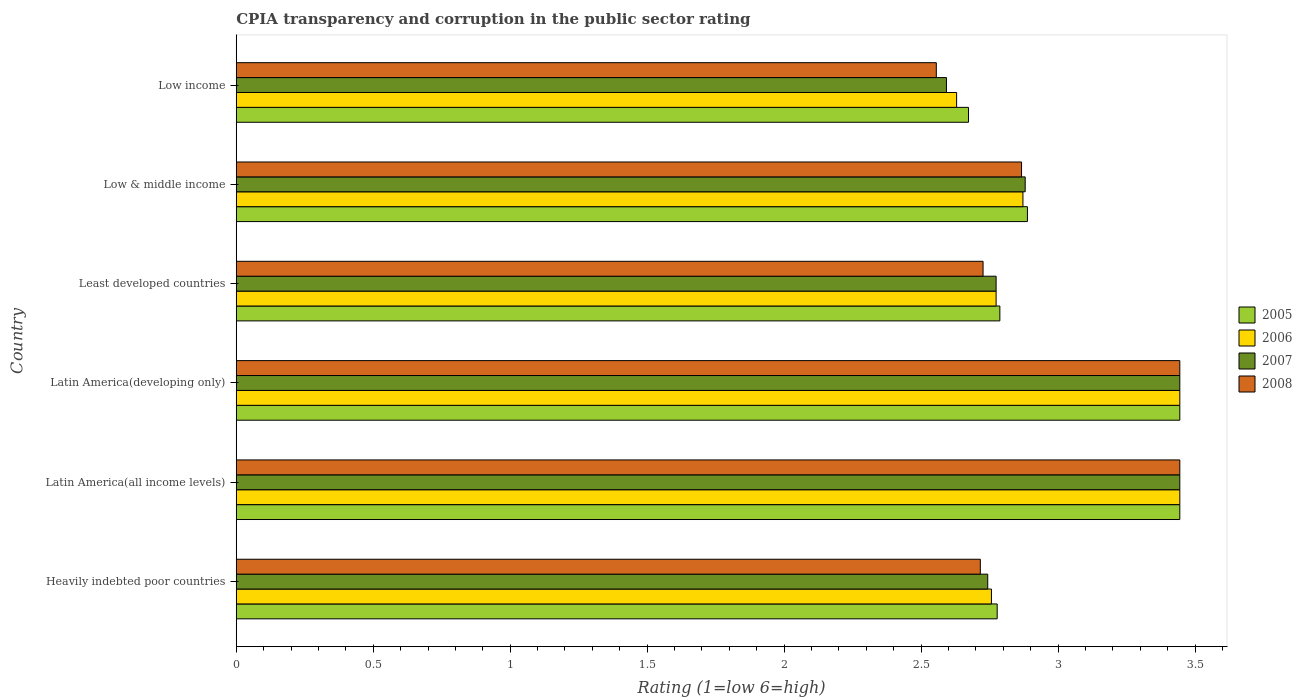Are the number of bars on each tick of the Y-axis equal?
Make the answer very short. Yes. How many bars are there on the 4th tick from the top?
Offer a terse response. 4. What is the label of the 3rd group of bars from the top?
Offer a terse response. Least developed countries. What is the CPIA rating in 2007 in Least developed countries?
Your response must be concise. 2.77. Across all countries, what is the maximum CPIA rating in 2005?
Provide a succinct answer. 3.44. Across all countries, what is the minimum CPIA rating in 2006?
Give a very brief answer. 2.63. In which country was the CPIA rating in 2007 maximum?
Provide a succinct answer. Latin America(all income levels). What is the total CPIA rating in 2005 in the graph?
Provide a succinct answer. 18.02. What is the difference between the CPIA rating in 2005 in Heavily indebted poor countries and that in Low & middle income?
Offer a very short reply. -0.11. What is the difference between the CPIA rating in 2005 in Least developed countries and the CPIA rating in 2007 in Low income?
Give a very brief answer. 0.19. What is the average CPIA rating in 2005 per country?
Provide a short and direct response. 3. What is the difference between the CPIA rating in 2005 and CPIA rating in 2006 in Least developed countries?
Keep it short and to the point. 0.01. In how many countries, is the CPIA rating in 2006 greater than 1.5 ?
Your answer should be very brief. 6. What is the ratio of the CPIA rating in 2005 in Latin America(all income levels) to that in Latin America(developing only)?
Your answer should be compact. 1. Is the CPIA rating in 2005 in Least developed countries less than that in Low income?
Provide a short and direct response. No. What is the difference between the highest and the lowest CPIA rating in 2007?
Your answer should be very brief. 0.85. In how many countries, is the CPIA rating in 2005 greater than the average CPIA rating in 2005 taken over all countries?
Give a very brief answer. 2. What does the 3rd bar from the top in Least developed countries represents?
Offer a very short reply. 2006. Is it the case that in every country, the sum of the CPIA rating in 2005 and CPIA rating in 2006 is greater than the CPIA rating in 2008?
Your answer should be compact. Yes. How many bars are there?
Keep it short and to the point. 24. Are all the bars in the graph horizontal?
Offer a terse response. Yes. What is the difference between two consecutive major ticks on the X-axis?
Ensure brevity in your answer.  0.5. Does the graph contain any zero values?
Provide a short and direct response. No. Does the graph contain grids?
Give a very brief answer. No. How are the legend labels stacked?
Offer a terse response. Vertical. What is the title of the graph?
Your answer should be compact. CPIA transparency and corruption in the public sector rating. What is the label or title of the Y-axis?
Offer a very short reply. Country. What is the Rating (1=low 6=high) of 2005 in Heavily indebted poor countries?
Provide a short and direct response. 2.78. What is the Rating (1=low 6=high) of 2006 in Heavily indebted poor countries?
Keep it short and to the point. 2.76. What is the Rating (1=low 6=high) of 2007 in Heavily indebted poor countries?
Give a very brief answer. 2.74. What is the Rating (1=low 6=high) in 2008 in Heavily indebted poor countries?
Give a very brief answer. 2.72. What is the Rating (1=low 6=high) of 2005 in Latin America(all income levels)?
Provide a short and direct response. 3.44. What is the Rating (1=low 6=high) in 2006 in Latin America(all income levels)?
Your answer should be compact. 3.44. What is the Rating (1=low 6=high) in 2007 in Latin America(all income levels)?
Your answer should be compact. 3.44. What is the Rating (1=low 6=high) in 2008 in Latin America(all income levels)?
Keep it short and to the point. 3.44. What is the Rating (1=low 6=high) in 2005 in Latin America(developing only)?
Keep it short and to the point. 3.44. What is the Rating (1=low 6=high) in 2006 in Latin America(developing only)?
Offer a very short reply. 3.44. What is the Rating (1=low 6=high) of 2007 in Latin America(developing only)?
Offer a very short reply. 3.44. What is the Rating (1=low 6=high) of 2008 in Latin America(developing only)?
Your answer should be compact. 3.44. What is the Rating (1=low 6=high) of 2005 in Least developed countries?
Offer a terse response. 2.79. What is the Rating (1=low 6=high) of 2006 in Least developed countries?
Offer a very short reply. 2.77. What is the Rating (1=low 6=high) in 2007 in Least developed countries?
Your response must be concise. 2.77. What is the Rating (1=low 6=high) in 2008 in Least developed countries?
Keep it short and to the point. 2.73. What is the Rating (1=low 6=high) in 2005 in Low & middle income?
Give a very brief answer. 2.89. What is the Rating (1=low 6=high) in 2006 in Low & middle income?
Provide a succinct answer. 2.87. What is the Rating (1=low 6=high) in 2007 in Low & middle income?
Your answer should be compact. 2.88. What is the Rating (1=low 6=high) in 2008 in Low & middle income?
Your answer should be compact. 2.87. What is the Rating (1=low 6=high) of 2005 in Low income?
Provide a short and direct response. 2.67. What is the Rating (1=low 6=high) of 2006 in Low income?
Your answer should be compact. 2.63. What is the Rating (1=low 6=high) in 2007 in Low income?
Offer a very short reply. 2.59. What is the Rating (1=low 6=high) of 2008 in Low income?
Offer a terse response. 2.56. Across all countries, what is the maximum Rating (1=low 6=high) in 2005?
Provide a short and direct response. 3.44. Across all countries, what is the maximum Rating (1=low 6=high) of 2006?
Your response must be concise. 3.44. Across all countries, what is the maximum Rating (1=low 6=high) in 2007?
Keep it short and to the point. 3.44. Across all countries, what is the maximum Rating (1=low 6=high) of 2008?
Provide a succinct answer. 3.44. Across all countries, what is the minimum Rating (1=low 6=high) in 2005?
Give a very brief answer. 2.67. Across all countries, what is the minimum Rating (1=low 6=high) of 2006?
Your answer should be compact. 2.63. Across all countries, what is the minimum Rating (1=low 6=high) in 2007?
Keep it short and to the point. 2.59. Across all countries, what is the minimum Rating (1=low 6=high) of 2008?
Keep it short and to the point. 2.56. What is the total Rating (1=low 6=high) of 2005 in the graph?
Offer a very short reply. 18.02. What is the total Rating (1=low 6=high) in 2006 in the graph?
Keep it short and to the point. 17.92. What is the total Rating (1=low 6=high) of 2007 in the graph?
Ensure brevity in your answer.  17.88. What is the total Rating (1=low 6=high) in 2008 in the graph?
Offer a terse response. 17.75. What is the difference between the Rating (1=low 6=high) in 2006 in Heavily indebted poor countries and that in Latin America(all income levels)?
Your answer should be compact. -0.69. What is the difference between the Rating (1=low 6=high) of 2007 in Heavily indebted poor countries and that in Latin America(all income levels)?
Give a very brief answer. -0.7. What is the difference between the Rating (1=low 6=high) in 2008 in Heavily indebted poor countries and that in Latin America(all income levels)?
Offer a very short reply. -0.73. What is the difference between the Rating (1=low 6=high) in 2006 in Heavily indebted poor countries and that in Latin America(developing only)?
Ensure brevity in your answer.  -0.69. What is the difference between the Rating (1=low 6=high) in 2007 in Heavily indebted poor countries and that in Latin America(developing only)?
Your answer should be compact. -0.7. What is the difference between the Rating (1=low 6=high) of 2008 in Heavily indebted poor countries and that in Latin America(developing only)?
Your response must be concise. -0.73. What is the difference between the Rating (1=low 6=high) of 2005 in Heavily indebted poor countries and that in Least developed countries?
Offer a very short reply. -0.01. What is the difference between the Rating (1=low 6=high) in 2006 in Heavily indebted poor countries and that in Least developed countries?
Give a very brief answer. -0.02. What is the difference between the Rating (1=low 6=high) in 2007 in Heavily indebted poor countries and that in Least developed countries?
Ensure brevity in your answer.  -0.03. What is the difference between the Rating (1=low 6=high) in 2008 in Heavily indebted poor countries and that in Least developed countries?
Your answer should be very brief. -0.01. What is the difference between the Rating (1=low 6=high) in 2005 in Heavily indebted poor countries and that in Low & middle income?
Provide a short and direct response. -0.11. What is the difference between the Rating (1=low 6=high) of 2006 in Heavily indebted poor countries and that in Low & middle income?
Provide a succinct answer. -0.12. What is the difference between the Rating (1=low 6=high) in 2007 in Heavily indebted poor countries and that in Low & middle income?
Give a very brief answer. -0.14. What is the difference between the Rating (1=low 6=high) in 2008 in Heavily indebted poor countries and that in Low & middle income?
Offer a very short reply. -0.15. What is the difference between the Rating (1=low 6=high) in 2005 in Heavily indebted poor countries and that in Low income?
Keep it short and to the point. 0.1. What is the difference between the Rating (1=low 6=high) in 2006 in Heavily indebted poor countries and that in Low income?
Give a very brief answer. 0.13. What is the difference between the Rating (1=low 6=high) of 2007 in Heavily indebted poor countries and that in Low income?
Your answer should be very brief. 0.15. What is the difference between the Rating (1=low 6=high) of 2008 in Heavily indebted poor countries and that in Low income?
Provide a short and direct response. 0.16. What is the difference between the Rating (1=low 6=high) in 2005 in Latin America(all income levels) and that in Latin America(developing only)?
Provide a short and direct response. 0. What is the difference between the Rating (1=low 6=high) of 2008 in Latin America(all income levels) and that in Latin America(developing only)?
Your answer should be compact. 0. What is the difference between the Rating (1=low 6=high) of 2005 in Latin America(all income levels) and that in Least developed countries?
Your answer should be compact. 0.66. What is the difference between the Rating (1=low 6=high) of 2006 in Latin America(all income levels) and that in Least developed countries?
Provide a short and direct response. 0.67. What is the difference between the Rating (1=low 6=high) in 2007 in Latin America(all income levels) and that in Least developed countries?
Offer a very short reply. 0.67. What is the difference between the Rating (1=low 6=high) in 2008 in Latin America(all income levels) and that in Least developed countries?
Keep it short and to the point. 0.72. What is the difference between the Rating (1=low 6=high) of 2005 in Latin America(all income levels) and that in Low & middle income?
Your answer should be very brief. 0.56. What is the difference between the Rating (1=low 6=high) in 2006 in Latin America(all income levels) and that in Low & middle income?
Your answer should be compact. 0.57. What is the difference between the Rating (1=low 6=high) of 2007 in Latin America(all income levels) and that in Low & middle income?
Your response must be concise. 0.56. What is the difference between the Rating (1=low 6=high) in 2008 in Latin America(all income levels) and that in Low & middle income?
Your answer should be very brief. 0.58. What is the difference between the Rating (1=low 6=high) in 2005 in Latin America(all income levels) and that in Low income?
Ensure brevity in your answer.  0.77. What is the difference between the Rating (1=low 6=high) in 2006 in Latin America(all income levels) and that in Low income?
Provide a succinct answer. 0.81. What is the difference between the Rating (1=low 6=high) of 2007 in Latin America(all income levels) and that in Low income?
Offer a terse response. 0.85. What is the difference between the Rating (1=low 6=high) in 2008 in Latin America(all income levels) and that in Low income?
Offer a very short reply. 0.89. What is the difference between the Rating (1=low 6=high) of 2005 in Latin America(developing only) and that in Least developed countries?
Give a very brief answer. 0.66. What is the difference between the Rating (1=low 6=high) in 2006 in Latin America(developing only) and that in Least developed countries?
Make the answer very short. 0.67. What is the difference between the Rating (1=low 6=high) in 2007 in Latin America(developing only) and that in Least developed countries?
Offer a terse response. 0.67. What is the difference between the Rating (1=low 6=high) of 2008 in Latin America(developing only) and that in Least developed countries?
Provide a short and direct response. 0.72. What is the difference between the Rating (1=low 6=high) in 2005 in Latin America(developing only) and that in Low & middle income?
Offer a very short reply. 0.56. What is the difference between the Rating (1=low 6=high) in 2006 in Latin America(developing only) and that in Low & middle income?
Your response must be concise. 0.57. What is the difference between the Rating (1=low 6=high) of 2007 in Latin America(developing only) and that in Low & middle income?
Make the answer very short. 0.56. What is the difference between the Rating (1=low 6=high) of 2008 in Latin America(developing only) and that in Low & middle income?
Your answer should be very brief. 0.58. What is the difference between the Rating (1=low 6=high) of 2005 in Latin America(developing only) and that in Low income?
Give a very brief answer. 0.77. What is the difference between the Rating (1=low 6=high) in 2006 in Latin America(developing only) and that in Low income?
Offer a terse response. 0.81. What is the difference between the Rating (1=low 6=high) of 2007 in Latin America(developing only) and that in Low income?
Your response must be concise. 0.85. What is the difference between the Rating (1=low 6=high) of 2005 in Least developed countries and that in Low & middle income?
Offer a very short reply. -0.1. What is the difference between the Rating (1=low 6=high) in 2006 in Least developed countries and that in Low & middle income?
Your answer should be compact. -0.1. What is the difference between the Rating (1=low 6=high) in 2007 in Least developed countries and that in Low & middle income?
Provide a short and direct response. -0.11. What is the difference between the Rating (1=low 6=high) in 2008 in Least developed countries and that in Low & middle income?
Your answer should be compact. -0.14. What is the difference between the Rating (1=low 6=high) in 2005 in Least developed countries and that in Low income?
Your response must be concise. 0.11. What is the difference between the Rating (1=low 6=high) of 2006 in Least developed countries and that in Low income?
Offer a very short reply. 0.14. What is the difference between the Rating (1=low 6=high) of 2007 in Least developed countries and that in Low income?
Your answer should be compact. 0.18. What is the difference between the Rating (1=low 6=high) in 2008 in Least developed countries and that in Low income?
Ensure brevity in your answer.  0.17. What is the difference between the Rating (1=low 6=high) of 2005 in Low & middle income and that in Low income?
Make the answer very short. 0.22. What is the difference between the Rating (1=low 6=high) in 2006 in Low & middle income and that in Low income?
Make the answer very short. 0.24. What is the difference between the Rating (1=low 6=high) in 2007 in Low & middle income and that in Low income?
Your response must be concise. 0.29. What is the difference between the Rating (1=low 6=high) of 2008 in Low & middle income and that in Low income?
Give a very brief answer. 0.31. What is the difference between the Rating (1=low 6=high) of 2006 in Heavily indebted poor countries and the Rating (1=low 6=high) of 2007 in Latin America(all income levels)?
Your answer should be very brief. -0.69. What is the difference between the Rating (1=low 6=high) in 2006 in Heavily indebted poor countries and the Rating (1=low 6=high) in 2008 in Latin America(all income levels)?
Your answer should be very brief. -0.69. What is the difference between the Rating (1=low 6=high) in 2007 in Heavily indebted poor countries and the Rating (1=low 6=high) in 2008 in Latin America(all income levels)?
Keep it short and to the point. -0.7. What is the difference between the Rating (1=low 6=high) of 2005 in Heavily indebted poor countries and the Rating (1=low 6=high) of 2006 in Latin America(developing only)?
Provide a short and direct response. -0.67. What is the difference between the Rating (1=low 6=high) in 2006 in Heavily indebted poor countries and the Rating (1=low 6=high) in 2007 in Latin America(developing only)?
Keep it short and to the point. -0.69. What is the difference between the Rating (1=low 6=high) of 2006 in Heavily indebted poor countries and the Rating (1=low 6=high) of 2008 in Latin America(developing only)?
Give a very brief answer. -0.69. What is the difference between the Rating (1=low 6=high) in 2007 in Heavily indebted poor countries and the Rating (1=low 6=high) in 2008 in Latin America(developing only)?
Your response must be concise. -0.7. What is the difference between the Rating (1=low 6=high) in 2005 in Heavily indebted poor countries and the Rating (1=low 6=high) in 2006 in Least developed countries?
Provide a succinct answer. 0. What is the difference between the Rating (1=low 6=high) in 2005 in Heavily indebted poor countries and the Rating (1=low 6=high) in 2007 in Least developed countries?
Make the answer very short. 0. What is the difference between the Rating (1=low 6=high) of 2005 in Heavily indebted poor countries and the Rating (1=low 6=high) of 2008 in Least developed countries?
Your answer should be very brief. 0.05. What is the difference between the Rating (1=low 6=high) of 2006 in Heavily indebted poor countries and the Rating (1=low 6=high) of 2007 in Least developed countries?
Keep it short and to the point. -0.02. What is the difference between the Rating (1=low 6=high) in 2006 in Heavily indebted poor countries and the Rating (1=low 6=high) in 2008 in Least developed countries?
Ensure brevity in your answer.  0.03. What is the difference between the Rating (1=low 6=high) of 2007 in Heavily indebted poor countries and the Rating (1=low 6=high) of 2008 in Least developed countries?
Offer a terse response. 0.02. What is the difference between the Rating (1=low 6=high) in 2005 in Heavily indebted poor countries and the Rating (1=low 6=high) in 2006 in Low & middle income?
Your answer should be compact. -0.09. What is the difference between the Rating (1=low 6=high) in 2005 in Heavily indebted poor countries and the Rating (1=low 6=high) in 2007 in Low & middle income?
Provide a short and direct response. -0.1. What is the difference between the Rating (1=low 6=high) in 2005 in Heavily indebted poor countries and the Rating (1=low 6=high) in 2008 in Low & middle income?
Provide a short and direct response. -0.09. What is the difference between the Rating (1=low 6=high) in 2006 in Heavily indebted poor countries and the Rating (1=low 6=high) in 2007 in Low & middle income?
Provide a succinct answer. -0.12. What is the difference between the Rating (1=low 6=high) in 2006 in Heavily indebted poor countries and the Rating (1=low 6=high) in 2008 in Low & middle income?
Give a very brief answer. -0.11. What is the difference between the Rating (1=low 6=high) in 2007 in Heavily indebted poor countries and the Rating (1=low 6=high) in 2008 in Low & middle income?
Provide a succinct answer. -0.12. What is the difference between the Rating (1=low 6=high) of 2005 in Heavily indebted poor countries and the Rating (1=low 6=high) of 2006 in Low income?
Keep it short and to the point. 0.15. What is the difference between the Rating (1=low 6=high) of 2005 in Heavily indebted poor countries and the Rating (1=low 6=high) of 2007 in Low income?
Your answer should be compact. 0.19. What is the difference between the Rating (1=low 6=high) of 2005 in Heavily indebted poor countries and the Rating (1=low 6=high) of 2008 in Low income?
Give a very brief answer. 0.22. What is the difference between the Rating (1=low 6=high) of 2006 in Heavily indebted poor countries and the Rating (1=low 6=high) of 2007 in Low income?
Provide a short and direct response. 0.16. What is the difference between the Rating (1=low 6=high) of 2006 in Heavily indebted poor countries and the Rating (1=low 6=high) of 2008 in Low income?
Give a very brief answer. 0.2. What is the difference between the Rating (1=low 6=high) in 2007 in Heavily indebted poor countries and the Rating (1=low 6=high) in 2008 in Low income?
Your answer should be compact. 0.19. What is the difference between the Rating (1=low 6=high) of 2006 in Latin America(all income levels) and the Rating (1=low 6=high) of 2007 in Latin America(developing only)?
Provide a short and direct response. 0. What is the difference between the Rating (1=low 6=high) in 2007 in Latin America(all income levels) and the Rating (1=low 6=high) in 2008 in Latin America(developing only)?
Your answer should be compact. 0. What is the difference between the Rating (1=low 6=high) of 2005 in Latin America(all income levels) and the Rating (1=low 6=high) of 2006 in Least developed countries?
Keep it short and to the point. 0.67. What is the difference between the Rating (1=low 6=high) in 2005 in Latin America(all income levels) and the Rating (1=low 6=high) in 2007 in Least developed countries?
Your response must be concise. 0.67. What is the difference between the Rating (1=low 6=high) of 2005 in Latin America(all income levels) and the Rating (1=low 6=high) of 2008 in Least developed countries?
Provide a short and direct response. 0.72. What is the difference between the Rating (1=low 6=high) in 2006 in Latin America(all income levels) and the Rating (1=low 6=high) in 2007 in Least developed countries?
Offer a very short reply. 0.67. What is the difference between the Rating (1=low 6=high) in 2006 in Latin America(all income levels) and the Rating (1=low 6=high) in 2008 in Least developed countries?
Offer a terse response. 0.72. What is the difference between the Rating (1=low 6=high) in 2007 in Latin America(all income levels) and the Rating (1=low 6=high) in 2008 in Least developed countries?
Provide a short and direct response. 0.72. What is the difference between the Rating (1=low 6=high) of 2005 in Latin America(all income levels) and the Rating (1=low 6=high) of 2006 in Low & middle income?
Keep it short and to the point. 0.57. What is the difference between the Rating (1=low 6=high) of 2005 in Latin America(all income levels) and the Rating (1=low 6=high) of 2007 in Low & middle income?
Offer a very short reply. 0.56. What is the difference between the Rating (1=low 6=high) of 2005 in Latin America(all income levels) and the Rating (1=low 6=high) of 2008 in Low & middle income?
Offer a terse response. 0.58. What is the difference between the Rating (1=low 6=high) of 2006 in Latin America(all income levels) and the Rating (1=low 6=high) of 2007 in Low & middle income?
Your answer should be very brief. 0.56. What is the difference between the Rating (1=low 6=high) in 2006 in Latin America(all income levels) and the Rating (1=low 6=high) in 2008 in Low & middle income?
Give a very brief answer. 0.58. What is the difference between the Rating (1=low 6=high) in 2007 in Latin America(all income levels) and the Rating (1=low 6=high) in 2008 in Low & middle income?
Offer a terse response. 0.58. What is the difference between the Rating (1=low 6=high) of 2005 in Latin America(all income levels) and the Rating (1=low 6=high) of 2006 in Low income?
Provide a short and direct response. 0.81. What is the difference between the Rating (1=low 6=high) of 2005 in Latin America(all income levels) and the Rating (1=low 6=high) of 2007 in Low income?
Offer a very short reply. 0.85. What is the difference between the Rating (1=low 6=high) of 2005 in Latin America(all income levels) and the Rating (1=low 6=high) of 2008 in Low income?
Offer a terse response. 0.89. What is the difference between the Rating (1=low 6=high) in 2006 in Latin America(all income levels) and the Rating (1=low 6=high) in 2007 in Low income?
Keep it short and to the point. 0.85. What is the difference between the Rating (1=low 6=high) of 2005 in Latin America(developing only) and the Rating (1=low 6=high) of 2006 in Least developed countries?
Give a very brief answer. 0.67. What is the difference between the Rating (1=low 6=high) of 2005 in Latin America(developing only) and the Rating (1=low 6=high) of 2007 in Least developed countries?
Offer a terse response. 0.67. What is the difference between the Rating (1=low 6=high) of 2005 in Latin America(developing only) and the Rating (1=low 6=high) of 2008 in Least developed countries?
Give a very brief answer. 0.72. What is the difference between the Rating (1=low 6=high) in 2006 in Latin America(developing only) and the Rating (1=low 6=high) in 2007 in Least developed countries?
Your response must be concise. 0.67. What is the difference between the Rating (1=low 6=high) in 2006 in Latin America(developing only) and the Rating (1=low 6=high) in 2008 in Least developed countries?
Your answer should be very brief. 0.72. What is the difference between the Rating (1=low 6=high) of 2007 in Latin America(developing only) and the Rating (1=low 6=high) of 2008 in Least developed countries?
Your answer should be compact. 0.72. What is the difference between the Rating (1=low 6=high) in 2005 in Latin America(developing only) and the Rating (1=low 6=high) in 2006 in Low & middle income?
Offer a terse response. 0.57. What is the difference between the Rating (1=low 6=high) of 2005 in Latin America(developing only) and the Rating (1=low 6=high) of 2007 in Low & middle income?
Provide a succinct answer. 0.56. What is the difference between the Rating (1=low 6=high) of 2005 in Latin America(developing only) and the Rating (1=low 6=high) of 2008 in Low & middle income?
Provide a short and direct response. 0.58. What is the difference between the Rating (1=low 6=high) in 2006 in Latin America(developing only) and the Rating (1=low 6=high) in 2007 in Low & middle income?
Ensure brevity in your answer.  0.56. What is the difference between the Rating (1=low 6=high) of 2006 in Latin America(developing only) and the Rating (1=low 6=high) of 2008 in Low & middle income?
Give a very brief answer. 0.58. What is the difference between the Rating (1=low 6=high) in 2007 in Latin America(developing only) and the Rating (1=low 6=high) in 2008 in Low & middle income?
Make the answer very short. 0.58. What is the difference between the Rating (1=low 6=high) in 2005 in Latin America(developing only) and the Rating (1=low 6=high) in 2006 in Low income?
Your response must be concise. 0.81. What is the difference between the Rating (1=low 6=high) of 2005 in Latin America(developing only) and the Rating (1=low 6=high) of 2007 in Low income?
Make the answer very short. 0.85. What is the difference between the Rating (1=low 6=high) of 2005 in Latin America(developing only) and the Rating (1=low 6=high) of 2008 in Low income?
Your answer should be very brief. 0.89. What is the difference between the Rating (1=low 6=high) of 2006 in Latin America(developing only) and the Rating (1=low 6=high) of 2007 in Low income?
Your answer should be very brief. 0.85. What is the difference between the Rating (1=low 6=high) in 2007 in Latin America(developing only) and the Rating (1=low 6=high) in 2008 in Low income?
Your answer should be compact. 0.89. What is the difference between the Rating (1=low 6=high) of 2005 in Least developed countries and the Rating (1=low 6=high) of 2006 in Low & middle income?
Your response must be concise. -0.08. What is the difference between the Rating (1=low 6=high) in 2005 in Least developed countries and the Rating (1=low 6=high) in 2007 in Low & middle income?
Your response must be concise. -0.09. What is the difference between the Rating (1=low 6=high) of 2005 in Least developed countries and the Rating (1=low 6=high) of 2008 in Low & middle income?
Your response must be concise. -0.08. What is the difference between the Rating (1=low 6=high) in 2006 in Least developed countries and the Rating (1=low 6=high) in 2007 in Low & middle income?
Provide a succinct answer. -0.11. What is the difference between the Rating (1=low 6=high) in 2006 in Least developed countries and the Rating (1=low 6=high) in 2008 in Low & middle income?
Your answer should be very brief. -0.09. What is the difference between the Rating (1=low 6=high) of 2007 in Least developed countries and the Rating (1=low 6=high) of 2008 in Low & middle income?
Provide a short and direct response. -0.09. What is the difference between the Rating (1=low 6=high) of 2005 in Least developed countries and the Rating (1=low 6=high) of 2006 in Low income?
Ensure brevity in your answer.  0.16. What is the difference between the Rating (1=low 6=high) of 2005 in Least developed countries and the Rating (1=low 6=high) of 2007 in Low income?
Ensure brevity in your answer.  0.19. What is the difference between the Rating (1=low 6=high) of 2005 in Least developed countries and the Rating (1=low 6=high) of 2008 in Low income?
Give a very brief answer. 0.23. What is the difference between the Rating (1=low 6=high) of 2006 in Least developed countries and the Rating (1=low 6=high) of 2007 in Low income?
Make the answer very short. 0.18. What is the difference between the Rating (1=low 6=high) in 2006 in Least developed countries and the Rating (1=low 6=high) in 2008 in Low income?
Your response must be concise. 0.22. What is the difference between the Rating (1=low 6=high) of 2007 in Least developed countries and the Rating (1=low 6=high) of 2008 in Low income?
Make the answer very short. 0.22. What is the difference between the Rating (1=low 6=high) in 2005 in Low & middle income and the Rating (1=low 6=high) in 2006 in Low income?
Make the answer very short. 0.26. What is the difference between the Rating (1=low 6=high) in 2005 in Low & middle income and the Rating (1=low 6=high) in 2007 in Low income?
Ensure brevity in your answer.  0.3. What is the difference between the Rating (1=low 6=high) of 2005 in Low & middle income and the Rating (1=low 6=high) of 2008 in Low income?
Your answer should be compact. 0.33. What is the difference between the Rating (1=low 6=high) of 2006 in Low & middle income and the Rating (1=low 6=high) of 2007 in Low income?
Provide a succinct answer. 0.28. What is the difference between the Rating (1=low 6=high) of 2006 in Low & middle income and the Rating (1=low 6=high) of 2008 in Low income?
Offer a terse response. 0.32. What is the difference between the Rating (1=low 6=high) in 2007 in Low & middle income and the Rating (1=low 6=high) in 2008 in Low income?
Ensure brevity in your answer.  0.32. What is the average Rating (1=low 6=high) of 2005 per country?
Make the answer very short. 3. What is the average Rating (1=low 6=high) of 2006 per country?
Your answer should be very brief. 2.99. What is the average Rating (1=low 6=high) of 2007 per country?
Ensure brevity in your answer.  2.98. What is the average Rating (1=low 6=high) in 2008 per country?
Offer a terse response. 2.96. What is the difference between the Rating (1=low 6=high) in 2005 and Rating (1=low 6=high) in 2006 in Heavily indebted poor countries?
Give a very brief answer. 0.02. What is the difference between the Rating (1=low 6=high) in 2005 and Rating (1=low 6=high) in 2007 in Heavily indebted poor countries?
Provide a succinct answer. 0.03. What is the difference between the Rating (1=low 6=high) of 2005 and Rating (1=low 6=high) of 2008 in Heavily indebted poor countries?
Keep it short and to the point. 0.06. What is the difference between the Rating (1=low 6=high) of 2006 and Rating (1=low 6=high) of 2007 in Heavily indebted poor countries?
Offer a terse response. 0.01. What is the difference between the Rating (1=low 6=high) in 2006 and Rating (1=low 6=high) in 2008 in Heavily indebted poor countries?
Keep it short and to the point. 0.04. What is the difference between the Rating (1=low 6=high) in 2007 and Rating (1=low 6=high) in 2008 in Heavily indebted poor countries?
Offer a very short reply. 0.03. What is the difference between the Rating (1=low 6=high) of 2005 and Rating (1=low 6=high) of 2006 in Latin America(all income levels)?
Make the answer very short. 0. What is the difference between the Rating (1=low 6=high) of 2005 and Rating (1=low 6=high) of 2008 in Latin America(all income levels)?
Offer a terse response. 0. What is the difference between the Rating (1=low 6=high) in 2006 and Rating (1=low 6=high) in 2008 in Latin America(all income levels)?
Your answer should be compact. 0. What is the difference between the Rating (1=low 6=high) in 2007 and Rating (1=low 6=high) in 2008 in Latin America(all income levels)?
Keep it short and to the point. 0. What is the difference between the Rating (1=low 6=high) of 2005 and Rating (1=low 6=high) of 2006 in Latin America(developing only)?
Your answer should be very brief. 0. What is the difference between the Rating (1=low 6=high) in 2005 and Rating (1=low 6=high) in 2007 in Latin America(developing only)?
Keep it short and to the point. 0. What is the difference between the Rating (1=low 6=high) of 2005 and Rating (1=low 6=high) of 2008 in Latin America(developing only)?
Keep it short and to the point. 0. What is the difference between the Rating (1=low 6=high) of 2005 and Rating (1=low 6=high) of 2006 in Least developed countries?
Your response must be concise. 0.01. What is the difference between the Rating (1=low 6=high) of 2005 and Rating (1=low 6=high) of 2007 in Least developed countries?
Make the answer very short. 0.01. What is the difference between the Rating (1=low 6=high) in 2005 and Rating (1=low 6=high) in 2008 in Least developed countries?
Offer a very short reply. 0.06. What is the difference between the Rating (1=low 6=high) in 2006 and Rating (1=low 6=high) in 2008 in Least developed countries?
Give a very brief answer. 0.05. What is the difference between the Rating (1=low 6=high) in 2007 and Rating (1=low 6=high) in 2008 in Least developed countries?
Your answer should be very brief. 0.05. What is the difference between the Rating (1=low 6=high) in 2005 and Rating (1=low 6=high) in 2006 in Low & middle income?
Your answer should be compact. 0.02. What is the difference between the Rating (1=low 6=high) of 2005 and Rating (1=low 6=high) of 2007 in Low & middle income?
Give a very brief answer. 0.01. What is the difference between the Rating (1=low 6=high) of 2005 and Rating (1=low 6=high) of 2008 in Low & middle income?
Your response must be concise. 0.02. What is the difference between the Rating (1=low 6=high) in 2006 and Rating (1=low 6=high) in 2007 in Low & middle income?
Provide a succinct answer. -0.01. What is the difference between the Rating (1=low 6=high) in 2006 and Rating (1=low 6=high) in 2008 in Low & middle income?
Provide a succinct answer. 0.01. What is the difference between the Rating (1=low 6=high) in 2007 and Rating (1=low 6=high) in 2008 in Low & middle income?
Your answer should be very brief. 0.01. What is the difference between the Rating (1=low 6=high) of 2005 and Rating (1=low 6=high) of 2006 in Low income?
Provide a succinct answer. 0.04. What is the difference between the Rating (1=low 6=high) of 2005 and Rating (1=low 6=high) of 2007 in Low income?
Ensure brevity in your answer.  0.08. What is the difference between the Rating (1=low 6=high) in 2005 and Rating (1=low 6=high) in 2008 in Low income?
Offer a terse response. 0.12. What is the difference between the Rating (1=low 6=high) in 2006 and Rating (1=low 6=high) in 2007 in Low income?
Ensure brevity in your answer.  0.04. What is the difference between the Rating (1=low 6=high) in 2006 and Rating (1=low 6=high) in 2008 in Low income?
Your response must be concise. 0.07. What is the difference between the Rating (1=low 6=high) of 2007 and Rating (1=low 6=high) of 2008 in Low income?
Your answer should be compact. 0.04. What is the ratio of the Rating (1=low 6=high) of 2005 in Heavily indebted poor countries to that in Latin America(all income levels)?
Your answer should be compact. 0.81. What is the ratio of the Rating (1=low 6=high) in 2006 in Heavily indebted poor countries to that in Latin America(all income levels)?
Provide a succinct answer. 0.8. What is the ratio of the Rating (1=low 6=high) in 2007 in Heavily indebted poor countries to that in Latin America(all income levels)?
Provide a short and direct response. 0.8. What is the ratio of the Rating (1=low 6=high) of 2008 in Heavily indebted poor countries to that in Latin America(all income levels)?
Your answer should be compact. 0.79. What is the ratio of the Rating (1=low 6=high) of 2005 in Heavily indebted poor countries to that in Latin America(developing only)?
Your response must be concise. 0.81. What is the ratio of the Rating (1=low 6=high) of 2006 in Heavily indebted poor countries to that in Latin America(developing only)?
Your response must be concise. 0.8. What is the ratio of the Rating (1=low 6=high) in 2007 in Heavily indebted poor countries to that in Latin America(developing only)?
Your answer should be compact. 0.8. What is the ratio of the Rating (1=low 6=high) in 2008 in Heavily indebted poor countries to that in Latin America(developing only)?
Your answer should be very brief. 0.79. What is the ratio of the Rating (1=low 6=high) of 2005 in Heavily indebted poor countries to that in Least developed countries?
Your response must be concise. 1. What is the ratio of the Rating (1=low 6=high) of 2006 in Heavily indebted poor countries to that in Least developed countries?
Keep it short and to the point. 0.99. What is the ratio of the Rating (1=low 6=high) in 2007 in Heavily indebted poor countries to that in Least developed countries?
Give a very brief answer. 0.99. What is the ratio of the Rating (1=low 6=high) of 2005 in Heavily indebted poor countries to that in Low & middle income?
Your answer should be very brief. 0.96. What is the ratio of the Rating (1=low 6=high) of 2006 in Heavily indebted poor countries to that in Low & middle income?
Give a very brief answer. 0.96. What is the ratio of the Rating (1=low 6=high) of 2007 in Heavily indebted poor countries to that in Low & middle income?
Ensure brevity in your answer.  0.95. What is the ratio of the Rating (1=low 6=high) of 2008 in Heavily indebted poor countries to that in Low & middle income?
Offer a terse response. 0.95. What is the ratio of the Rating (1=low 6=high) of 2005 in Heavily indebted poor countries to that in Low income?
Give a very brief answer. 1.04. What is the ratio of the Rating (1=low 6=high) in 2006 in Heavily indebted poor countries to that in Low income?
Your response must be concise. 1.05. What is the ratio of the Rating (1=low 6=high) of 2007 in Heavily indebted poor countries to that in Low income?
Offer a terse response. 1.06. What is the ratio of the Rating (1=low 6=high) of 2008 in Heavily indebted poor countries to that in Low income?
Make the answer very short. 1.06. What is the ratio of the Rating (1=low 6=high) in 2005 in Latin America(all income levels) to that in Least developed countries?
Make the answer very short. 1.24. What is the ratio of the Rating (1=low 6=high) of 2006 in Latin America(all income levels) to that in Least developed countries?
Your response must be concise. 1.24. What is the ratio of the Rating (1=low 6=high) of 2007 in Latin America(all income levels) to that in Least developed countries?
Keep it short and to the point. 1.24. What is the ratio of the Rating (1=low 6=high) in 2008 in Latin America(all income levels) to that in Least developed countries?
Offer a very short reply. 1.26. What is the ratio of the Rating (1=low 6=high) in 2005 in Latin America(all income levels) to that in Low & middle income?
Your response must be concise. 1.19. What is the ratio of the Rating (1=low 6=high) in 2006 in Latin America(all income levels) to that in Low & middle income?
Your response must be concise. 1.2. What is the ratio of the Rating (1=low 6=high) in 2007 in Latin America(all income levels) to that in Low & middle income?
Your answer should be very brief. 1.2. What is the ratio of the Rating (1=low 6=high) of 2008 in Latin America(all income levels) to that in Low & middle income?
Provide a short and direct response. 1.2. What is the ratio of the Rating (1=low 6=high) of 2005 in Latin America(all income levels) to that in Low income?
Offer a terse response. 1.29. What is the ratio of the Rating (1=low 6=high) in 2006 in Latin America(all income levels) to that in Low income?
Make the answer very short. 1.31. What is the ratio of the Rating (1=low 6=high) in 2007 in Latin America(all income levels) to that in Low income?
Make the answer very short. 1.33. What is the ratio of the Rating (1=low 6=high) of 2008 in Latin America(all income levels) to that in Low income?
Make the answer very short. 1.35. What is the ratio of the Rating (1=low 6=high) of 2005 in Latin America(developing only) to that in Least developed countries?
Keep it short and to the point. 1.24. What is the ratio of the Rating (1=low 6=high) in 2006 in Latin America(developing only) to that in Least developed countries?
Keep it short and to the point. 1.24. What is the ratio of the Rating (1=low 6=high) of 2007 in Latin America(developing only) to that in Least developed countries?
Provide a succinct answer. 1.24. What is the ratio of the Rating (1=low 6=high) of 2008 in Latin America(developing only) to that in Least developed countries?
Ensure brevity in your answer.  1.26. What is the ratio of the Rating (1=low 6=high) of 2005 in Latin America(developing only) to that in Low & middle income?
Provide a short and direct response. 1.19. What is the ratio of the Rating (1=low 6=high) of 2006 in Latin America(developing only) to that in Low & middle income?
Keep it short and to the point. 1.2. What is the ratio of the Rating (1=low 6=high) of 2007 in Latin America(developing only) to that in Low & middle income?
Your answer should be very brief. 1.2. What is the ratio of the Rating (1=low 6=high) of 2008 in Latin America(developing only) to that in Low & middle income?
Keep it short and to the point. 1.2. What is the ratio of the Rating (1=low 6=high) in 2005 in Latin America(developing only) to that in Low income?
Keep it short and to the point. 1.29. What is the ratio of the Rating (1=low 6=high) in 2006 in Latin America(developing only) to that in Low income?
Your response must be concise. 1.31. What is the ratio of the Rating (1=low 6=high) of 2007 in Latin America(developing only) to that in Low income?
Make the answer very short. 1.33. What is the ratio of the Rating (1=low 6=high) in 2008 in Latin America(developing only) to that in Low income?
Offer a terse response. 1.35. What is the ratio of the Rating (1=low 6=high) in 2005 in Least developed countries to that in Low & middle income?
Give a very brief answer. 0.97. What is the ratio of the Rating (1=low 6=high) in 2006 in Least developed countries to that in Low & middle income?
Your response must be concise. 0.97. What is the ratio of the Rating (1=low 6=high) of 2007 in Least developed countries to that in Low & middle income?
Provide a short and direct response. 0.96. What is the ratio of the Rating (1=low 6=high) in 2008 in Least developed countries to that in Low & middle income?
Provide a succinct answer. 0.95. What is the ratio of the Rating (1=low 6=high) of 2005 in Least developed countries to that in Low income?
Keep it short and to the point. 1.04. What is the ratio of the Rating (1=low 6=high) of 2006 in Least developed countries to that in Low income?
Ensure brevity in your answer.  1.05. What is the ratio of the Rating (1=low 6=high) in 2007 in Least developed countries to that in Low income?
Provide a short and direct response. 1.07. What is the ratio of the Rating (1=low 6=high) of 2008 in Least developed countries to that in Low income?
Ensure brevity in your answer.  1.07. What is the ratio of the Rating (1=low 6=high) in 2005 in Low & middle income to that in Low income?
Offer a very short reply. 1.08. What is the ratio of the Rating (1=low 6=high) of 2006 in Low & middle income to that in Low income?
Provide a short and direct response. 1.09. What is the ratio of the Rating (1=low 6=high) of 2007 in Low & middle income to that in Low income?
Your answer should be compact. 1.11. What is the ratio of the Rating (1=low 6=high) in 2008 in Low & middle income to that in Low income?
Your answer should be very brief. 1.12. What is the difference between the highest and the second highest Rating (1=low 6=high) of 2005?
Offer a terse response. 0. What is the difference between the highest and the second highest Rating (1=low 6=high) in 2008?
Keep it short and to the point. 0. What is the difference between the highest and the lowest Rating (1=low 6=high) in 2005?
Your answer should be compact. 0.77. What is the difference between the highest and the lowest Rating (1=low 6=high) of 2006?
Ensure brevity in your answer.  0.81. What is the difference between the highest and the lowest Rating (1=low 6=high) in 2007?
Ensure brevity in your answer.  0.85. 